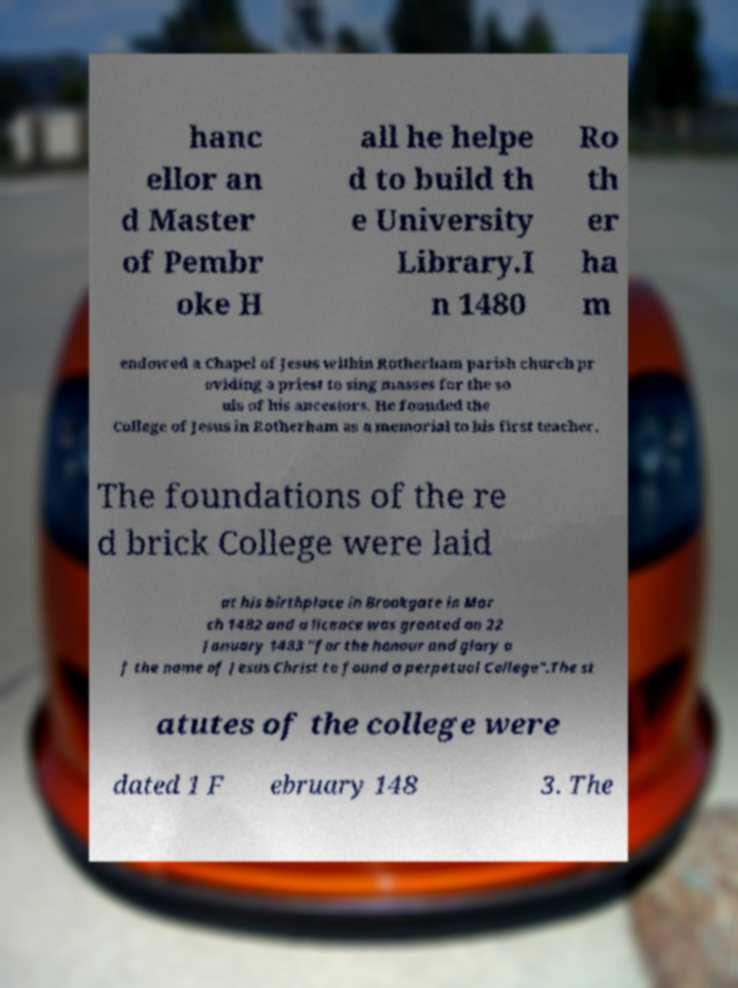For documentation purposes, I need the text within this image transcribed. Could you provide that? hanc ellor an d Master of Pembr oke H all he helpe d to build th e University Library.I n 1480 Ro th er ha m endowed a Chapel of Jesus within Rotherham parish church pr oviding a priest to sing masses for the so uls of his ancestors. He founded the College of Jesus in Rotherham as a memorial to his first teacher. The foundations of the re d brick College were laid at his birthplace in Brookgate in Mar ch 1482 and a licence was granted on 22 January 1483 "for the honour and glory o f the name of Jesus Christ to found a perpetual College".The st atutes of the college were dated 1 F ebruary 148 3. The 